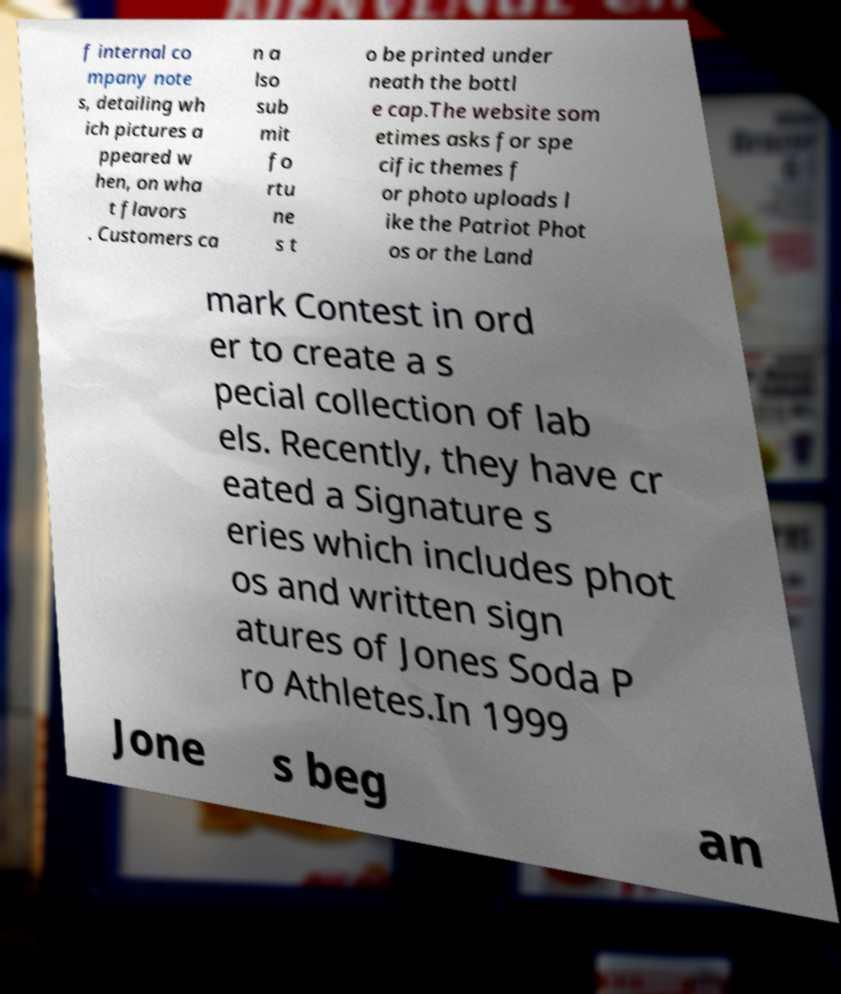Can you accurately transcribe the text from the provided image for me? f internal co mpany note s, detailing wh ich pictures a ppeared w hen, on wha t flavors . Customers ca n a lso sub mit fo rtu ne s t o be printed under neath the bottl e cap.The website som etimes asks for spe cific themes f or photo uploads l ike the Patriot Phot os or the Land mark Contest in ord er to create a s pecial collection of lab els. Recently, they have cr eated a Signature s eries which includes phot os and written sign atures of Jones Soda P ro Athletes.In 1999 Jone s beg an 